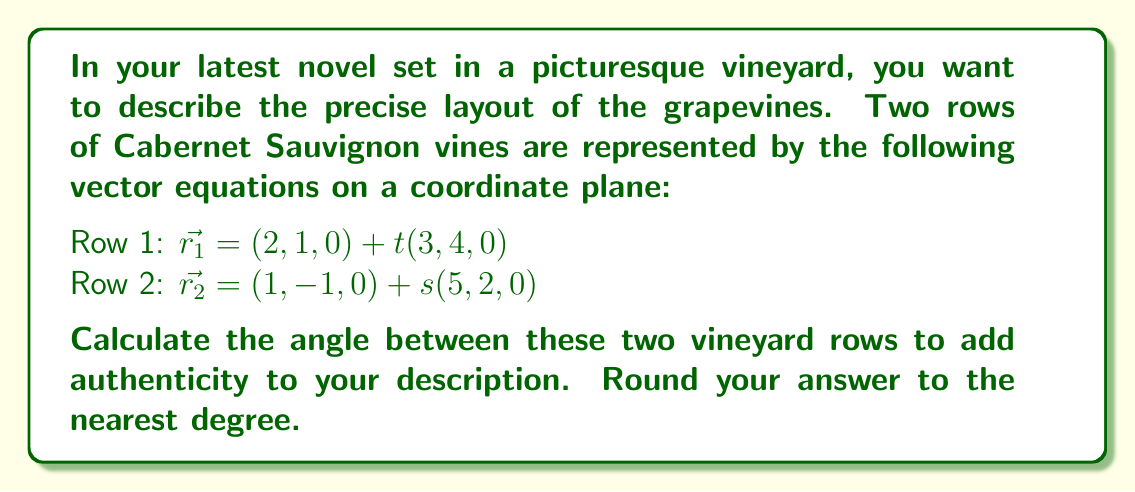Can you solve this math problem? To find the angle between two vectors, we can use the dot product formula:

$$\cos \theta = \frac{\vec{a} \cdot \vec{b}}{|\vec{a}||\vec{b}|}$$

Where $\vec{a}$ and $\vec{b}$ are the direction vectors of the two rows.

1) First, identify the direction vectors:
   Row 1: $\vec{a} = (3, 4, 0)$
   Row 2: $\vec{b} = (5, 2, 0)$

2) Calculate the dot product $\vec{a} \cdot \vec{b}$:
   $\vec{a} \cdot \vec{b} = (3)(5) + (4)(2) + (0)(0) = 15 + 8 = 23$

3) Calculate the magnitudes:
   $|\vec{a}| = \sqrt{3^2 + 4^2 + 0^2} = \sqrt{25} = 5$
   $|\vec{b}| = \sqrt{5^2 + 2^2 + 0^2} = \sqrt{29}$

4) Apply the formula:
   $$\cos \theta = \frac{23}{5\sqrt{29}}$$

5) Take the inverse cosine (arccos) of both sides:
   $$\theta = \arccos(\frac{23}{5\sqrt{29}})$$

6) Calculate and round to the nearest degree:
   $\theta \approx 22.6°$, which rounds to 23°
Answer: 23° 